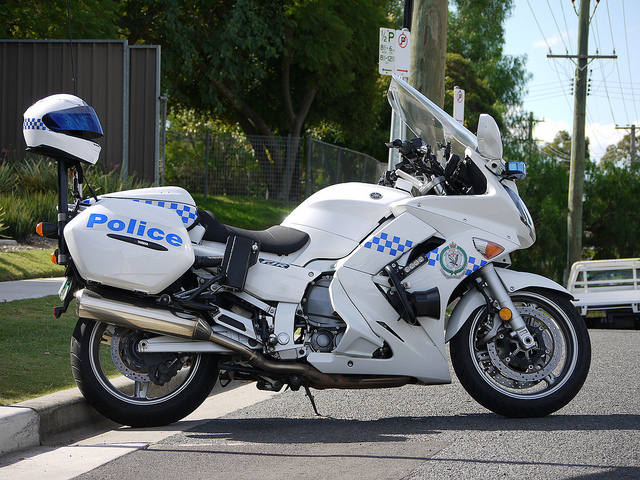Extract all visible text content from this image. Police P P 